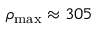<formula> <loc_0><loc_0><loc_500><loc_500>\rho _ { \max } \approx 3 0 5</formula> 